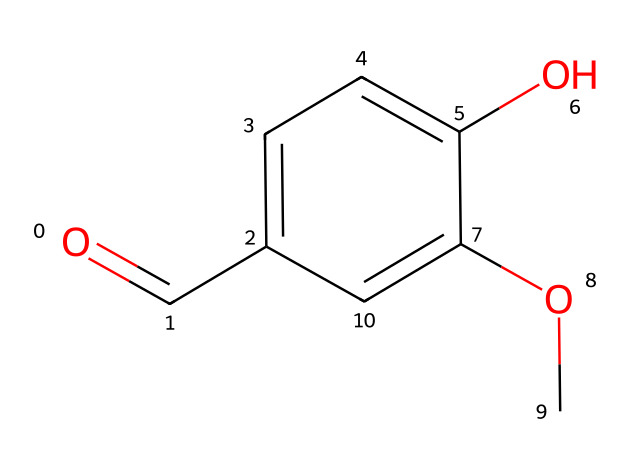How many carbon atoms are present in this chemical? By examining the SMILES notation, we can count the carbon atoms represented in the structure. The "c" and "C" indicate aromatic and aliphatic carbon atoms, respectively. In this case, there are a total of 10 carbon atoms.
Answer: 10 What functional groups are present in the chemical? Looking at the SMILES, the presence of "O=C" indicates a carbonyl group (ketone or aldehyde), and "OC" suggests an ether or methoxy group. The "OH" indicates a hydroxyl group, which is characteristic of phenols. Thus, the functional groups are carbonyl, methoxy, and hydroxyl.
Answer: carbonyl, methoxy, hydroxyl Which ring structure is indicated in this chemical? The notation "c" indicates a cyclic structure, specifically a benzene ring due to its alternating single and double bonds. Counting the "c" gives us six carbon atoms in a single aromatic ring.
Answer: benzene ring What characteristic scent type might this chemical impart? Due to the presence of the hydroxyl and methoxy groups on the aromatic ring, this compound likely has sweet or floral notes common in fragrances. The combination of these groups is typical in many traditional soft drink flavors.
Answer: sweet or floral How does the presence of the carbonyl group affect the aroma of this compound? The carbonyl group contributes to a rich, creamy, or vanilla-like scent. In many fragrances, carbonyl compounds play a role in enhancing the complexity and depth of the overall scent profile, often balancing and complementing sweeter notes.
Answer: rich, creamy, or vanilla-like What role do aromatic rings typically play in flavor and fragrance chemistry? Aromatic rings, like the one present in this compound, are fundamental in flavor and fragrance chemistry because they can stabilize volatile aromatic compounds. Their structure enhances the scent profile by allowing complex interactions with olfactory receptors.
Answer: stabilize volatile aromatic compounds 